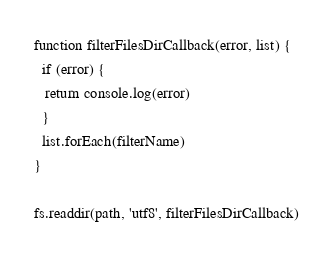<code> <loc_0><loc_0><loc_500><loc_500><_JavaScript_>
function filterFilesDirCallback(error, list) {
  if (error) {
   return console.log(error)
  }
  list.forEach(filterName)
}

fs.readdir(path, 'utf8', filterFilesDirCallback)
</code> 